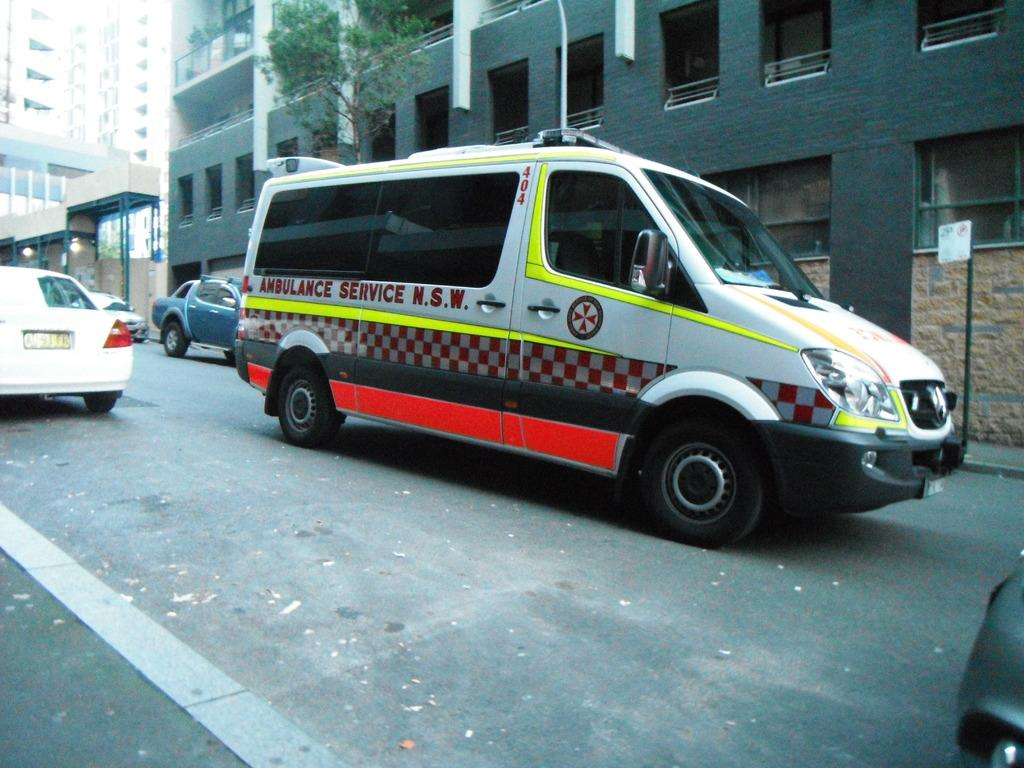<image>
Create a compact narrative representing the image presented. A white ambulance has the abbreviation N.S.W. painted on the side door. 